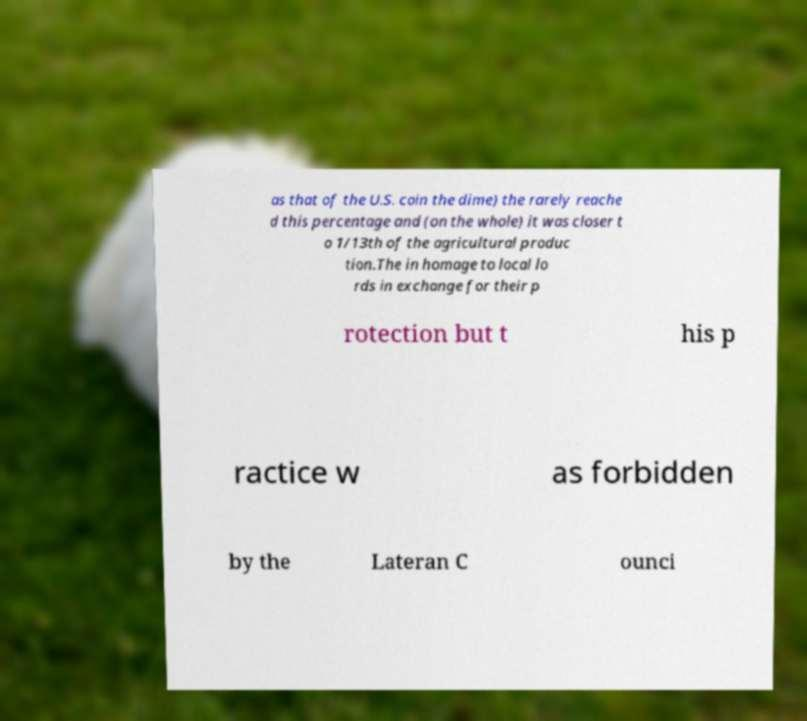Please read and relay the text visible in this image. What does it say? as that of the U.S. coin the dime) the rarely reache d this percentage and (on the whole) it was closer t o 1/13th of the agricultural produc tion.The in homage to local lo rds in exchange for their p rotection but t his p ractice w as forbidden by the Lateran C ounci 